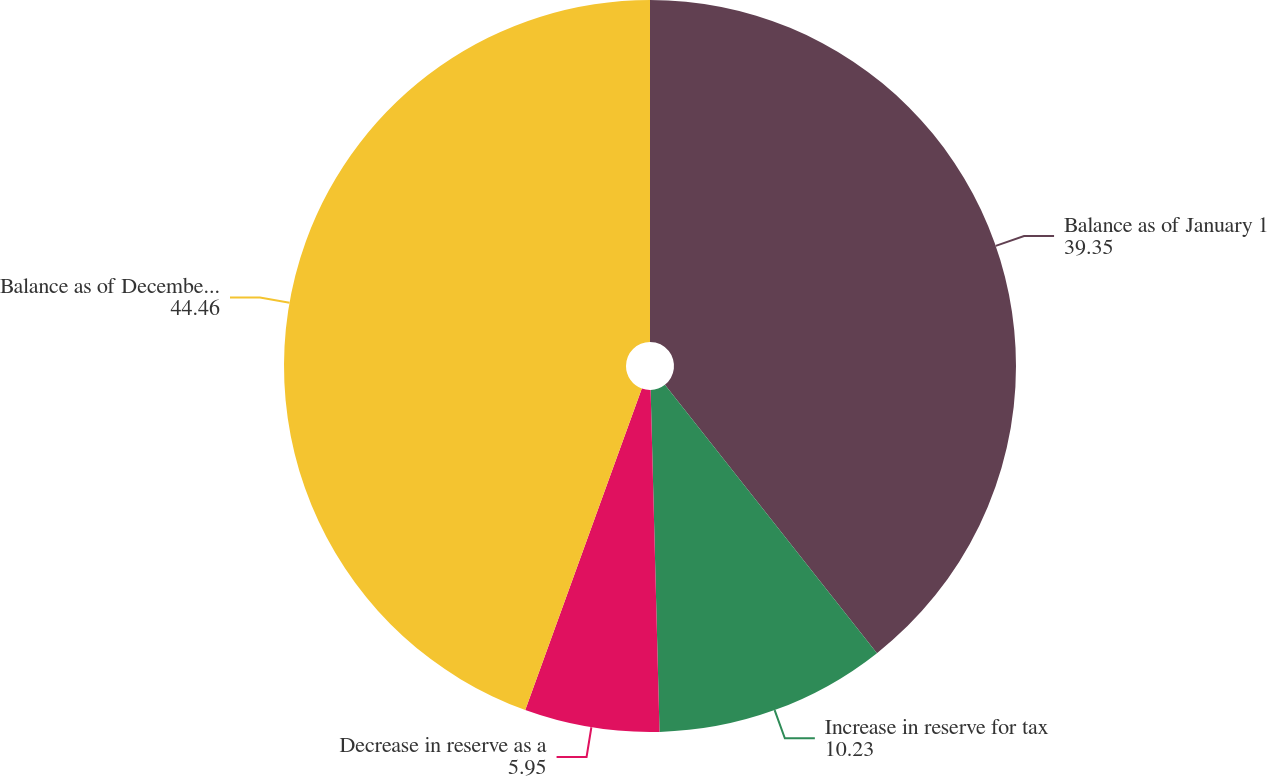<chart> <loc_0><loc_0><loc_500><loc_500><pie_chart><fcel>Balance as of January 1<fcel>Increase in reserve for tax<fcel>Decrease in reserve as a<fcel>Balance as of December 31<nl><fcel>39.35%<fcel>10.23%<fcel>5.95%<fcel>44.46%<nl></chart> 